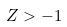<formula> <loc_0><loc_0><loc_500><loc_500>Z > - 1</formula> 